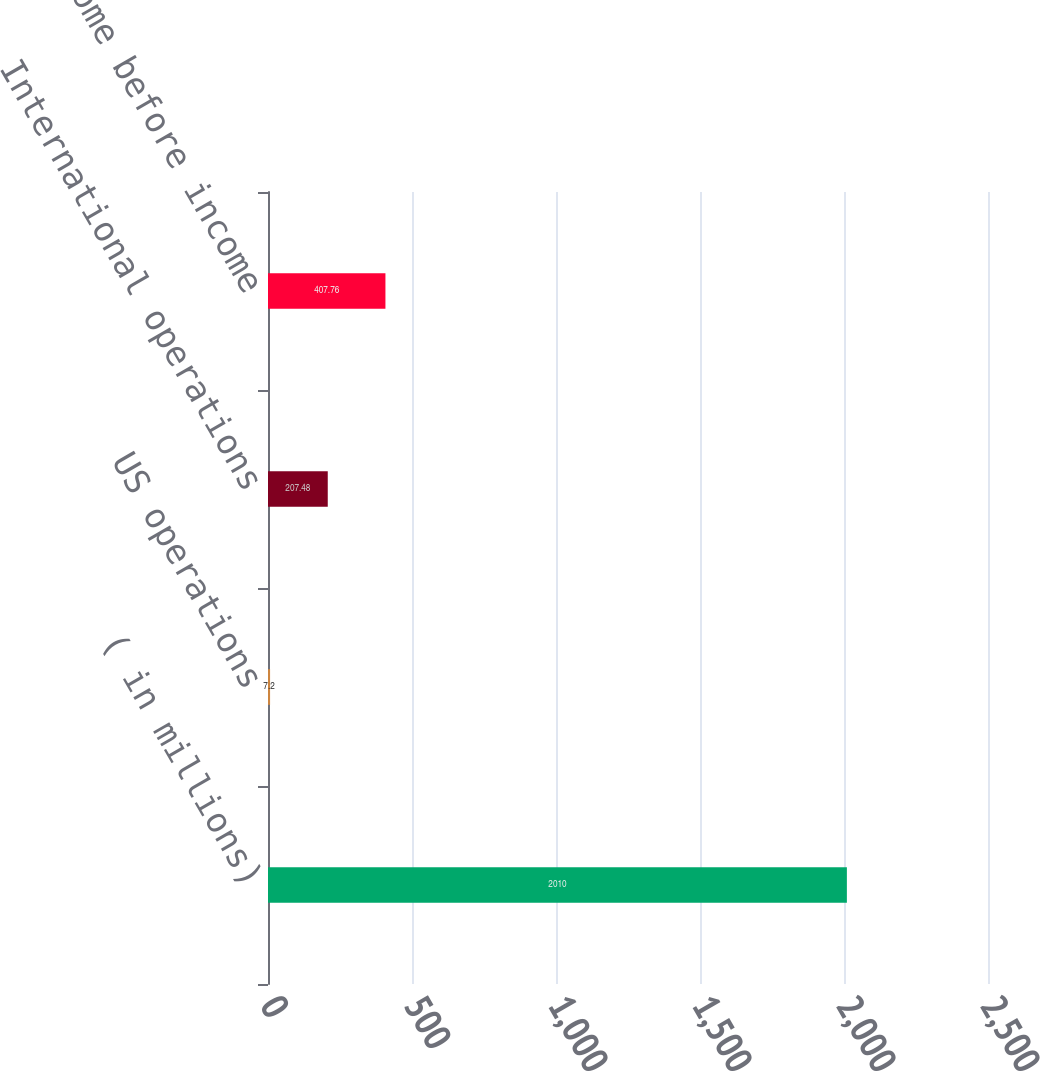<chart> <loc_0><loc_0><loc_500><loc_500><bar_chart><fcel>( in millions)<fcel>US operations<fcel>International operations<fcel>Total income before income<nl><fcel>2010<fcel>7.2<fcel>207.48<fcel>407.76<nl></chart> 